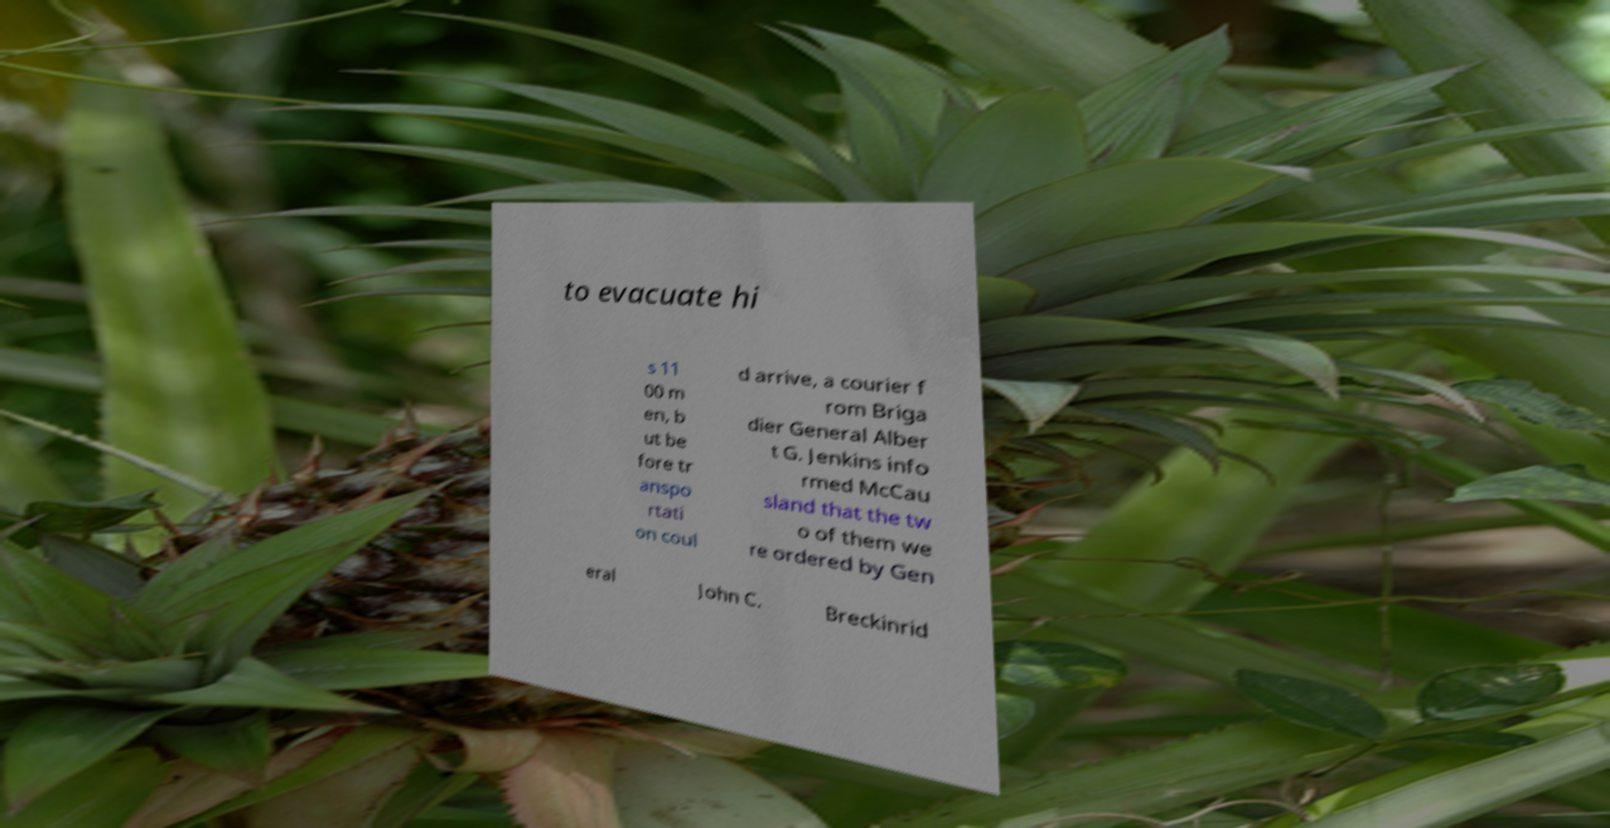Can you read and provide the text displayed in the image?This photo seems to have some interesting text. Can you extract and type it out for me? to evacuate hi s 11 00 m en, b ut be fore tr anspo rtati on coul d arrive, a courier f rom Briga dier General Alber t G. Jenkins info rmed McCau sland that the tw o of them we re ordered by Gen eral John C. Breckinrid 